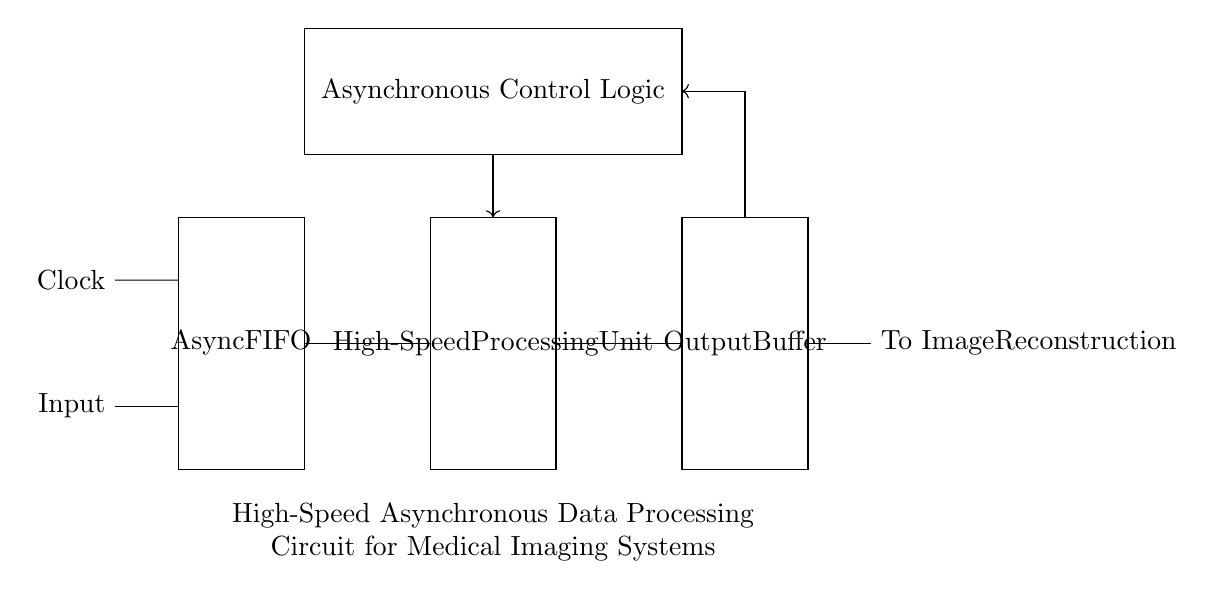What is the main purpose of the Async FIFO? The Async FIFO temporarily stores data, allowing for different clock domains between the input and processing unit, thus handling asynchronous data efficiently.
Answer: Temporary storage What are the three main components of this circuit? The main components in the circuit are the Async FIFO, High-Speed Processing Unit, and Output Buffer, clearly labeled within rectangles.
Answer: Async FIFO, High-Speed Processing Unit, Output Buffer What is the function of the Asynchronous Control Logic? The Asynchronous Control Logic coordinates the timing and control signals for data processing across the components, ensuring synchronization across asynchronous elements.
Answer: Coordination of timing How many connections are there from the High-Speed Processing Unit to the Output Buffer? There is one direct connection from the High-Speed Processing Unit to the Output Buffer, indicated by a single line connecting the two components in the diagram.
Answer: One connection Why is feedback utilized in this circuit? Feedback helps in regulating and controlling the output, allowing for adjustments back to the processing unit based on the output conditions, which improves overall system performance.
Answer: Regulation and control What type of circuit is depicted in this diagram? The circuit is described as a high-speed asynchronous data processing system, which implies that it operates without a global clock signal, allowing for faster and more flexible data handling.
Answer: High-speed asynchronous What does the term "High-Speed" refer to in this context? "High-Speed" signifies the capability of the processing unit to handle data at high rates, which is essential for rapidly processing medical imaging data for timely analysis.
Answer: Rapid data handling 